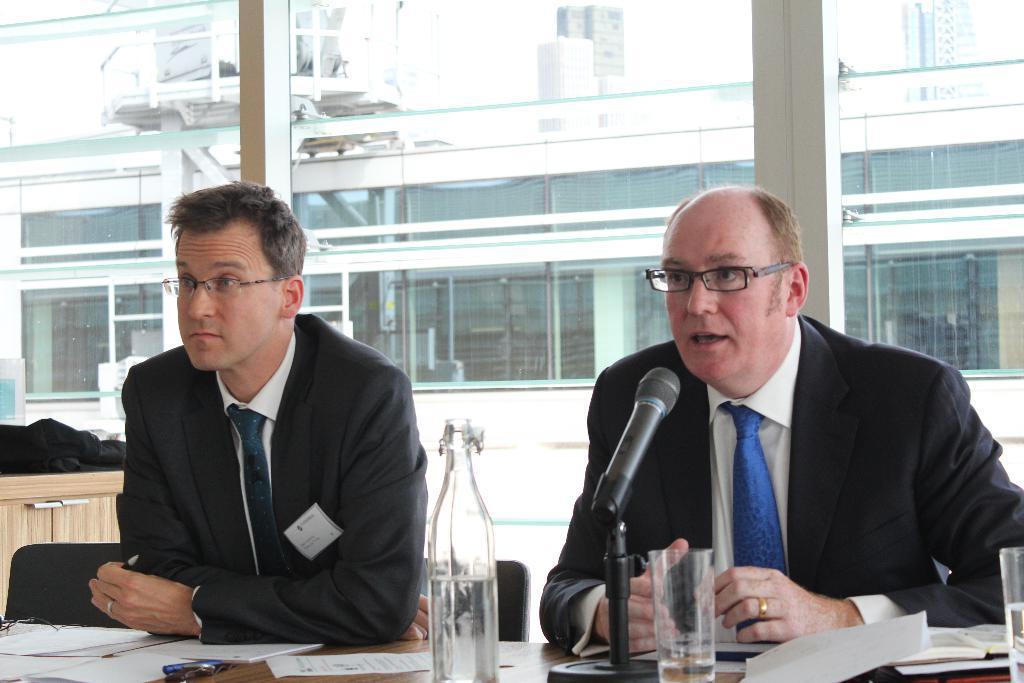In one or two sentences, can you explain what this image depicts? In this picture we can see two men wore spectacles, blazers, ties, sitting on chairs and in front of them we can see a bottle, glasses, papers, books, mic on the table and in the background we can see a building with windows and some objects. 